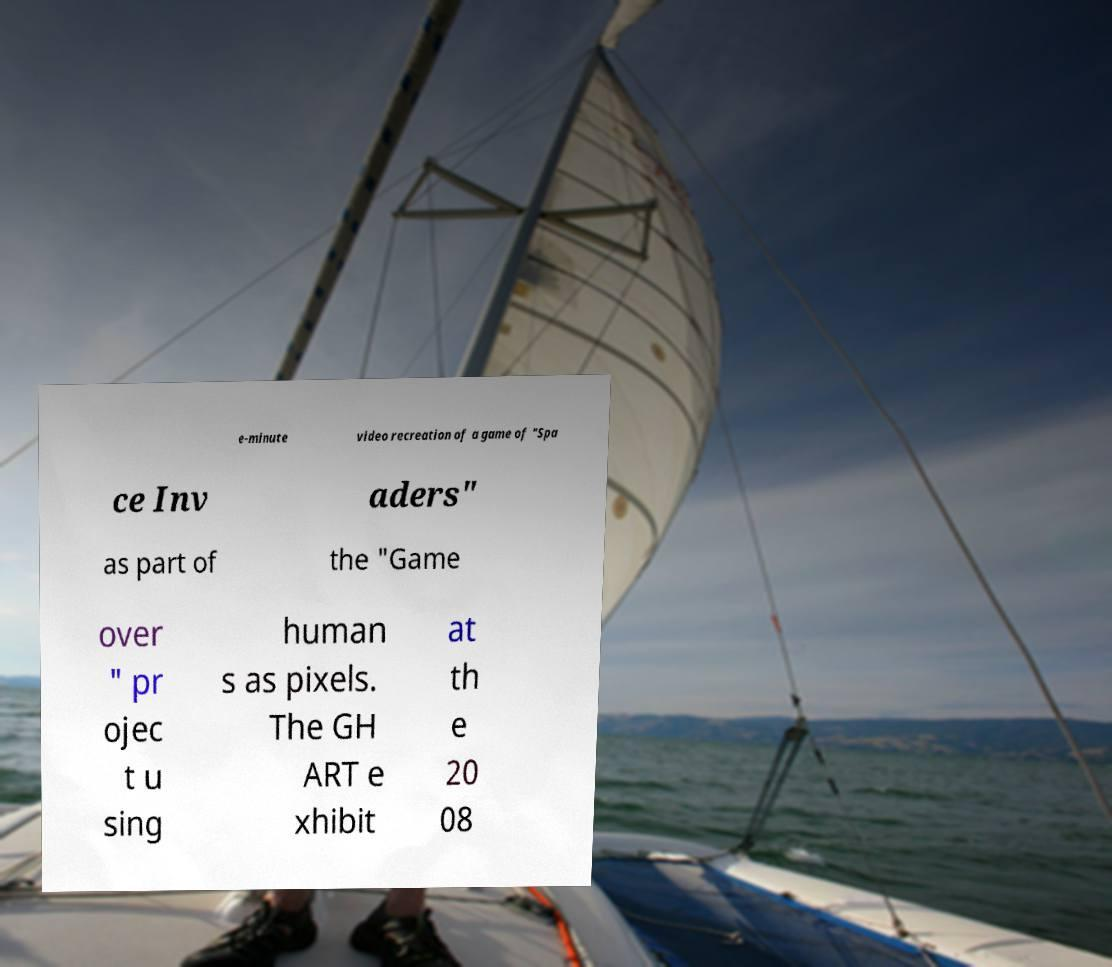Could you assist in decoding the text presented in this image and type it out clearly? e-minute video recreation of a game of "Spa ce Inv aders" as part of the "Game over " pr ojec t u sing human s as pixels. The GH ART e xhibit at th e 20 08 